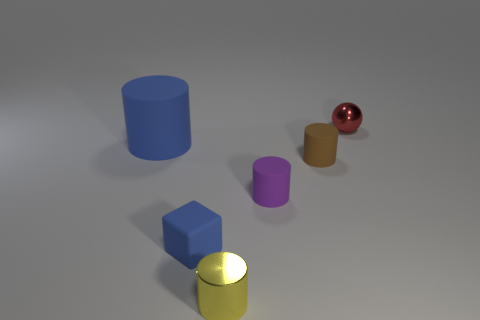Subtract 1 cylinders. How many cylinders are left? 3 Add 2 matte cubes. How many objects exist? 8 Subtract all spheres. How many objects are left? 5 Add 6 brown matte things. How many brown matte things are left? 7 Add 3 tiny brown things. How many tiny brown things exist? 4 Subtract 0 brown blocks. How many objects are left? 6 Subtract all red objects. Subtract all blue matte objects. How many objects are left? 3 